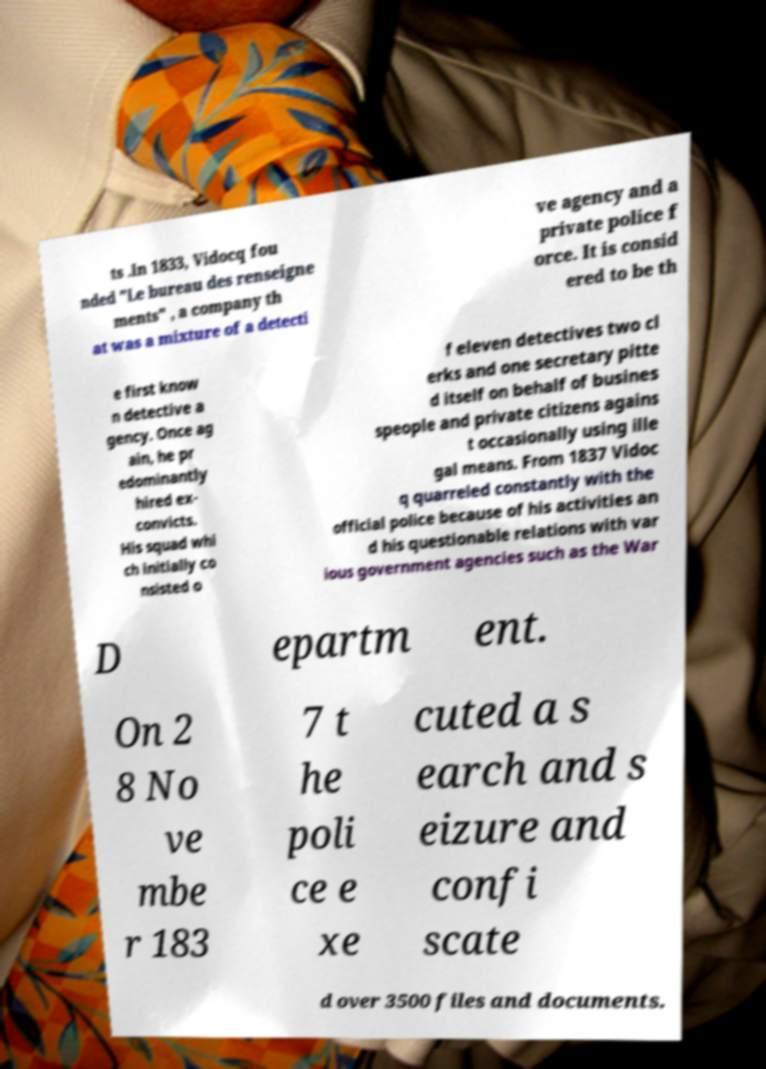There's text embedded in this image that I need extracted. Can you transcribe it verbatim? ts .In 1833, Vidocq fou nded "Le bureau des renseigne ments" , a company th at was a mixture of a detecti ve agency and a private police f orce. It is consid ered to be th e first know n detective a gency. Once ag ain, he pr edominantly hired ex- convicts. His squad whi ch initially co nsisted o f eleven detectives two cl erks and one secretary pitte d itself on behalf of busines speople and private citizens agains t occasionally using ille gal means. From 1837 Vidoc q quarreled constantly with the official police because of his activities an d his questionable relations with var ious government agencies such as the War D epartm ent. On 2 8 No ve mbe r 183 7 t he poli ce e xe cuted a s earch and s eizure and confi scate d over 3500 files and documents. 